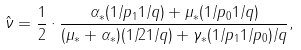<formula> <loc_0><loc_0><loc_500><loc_500>\hat { \nu } = \frac { 1 } { 2 } \cdot \frac { \alpha _ { * } ( 1 / p _ { 1 } 1 / q ) + \mu _ { * } ( 1 / p _ { 0 } 1 / q ) } { ( \mu _ { * } + \alpha _ { * } ) ( 1 / 2 1 / q ) + \gamma _ { * } ( 1 / p _ { 1 } 1 / p _ { 0 } ) / q } ,</formula> 